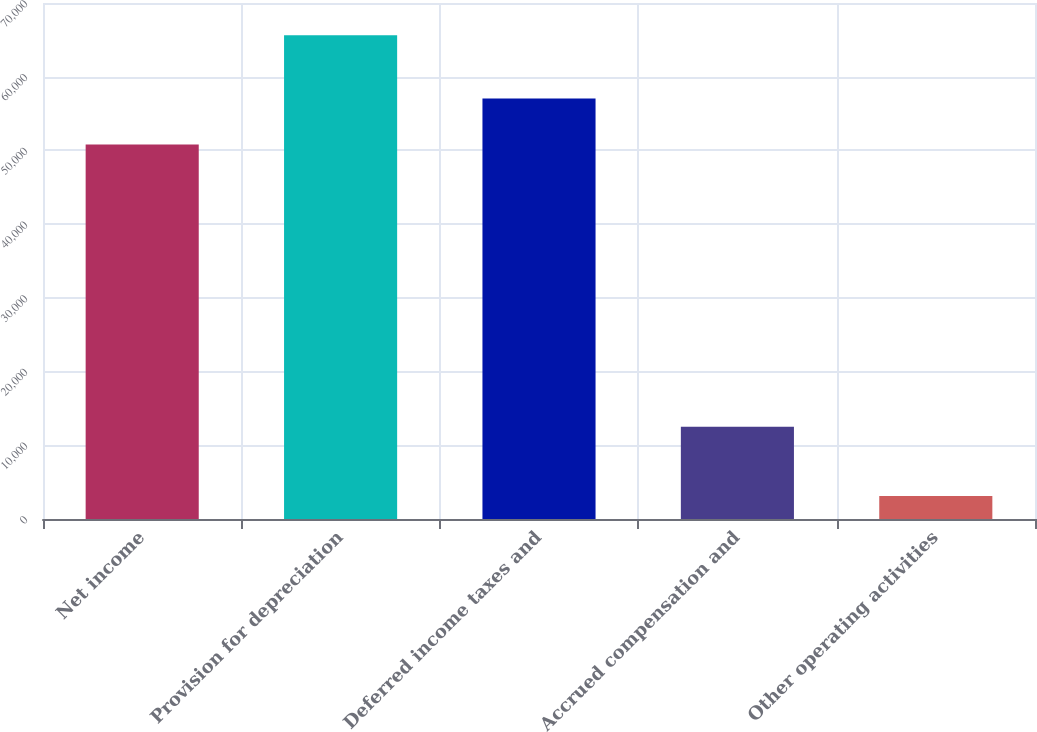Convert chart to OTSL. <chart><loc_0><loc_0><loc_500><loc_500><bar_chart><fcel>Net income<fcel>Provision for depreciation<fcel>Deferred income taxes and<fcel>Accrued compensation and<fcel>Other operating activities<nl><fcel>50798<fcel>65637<fcel>57051.3<fcel>12529<fcel>3104<nl></chart> 